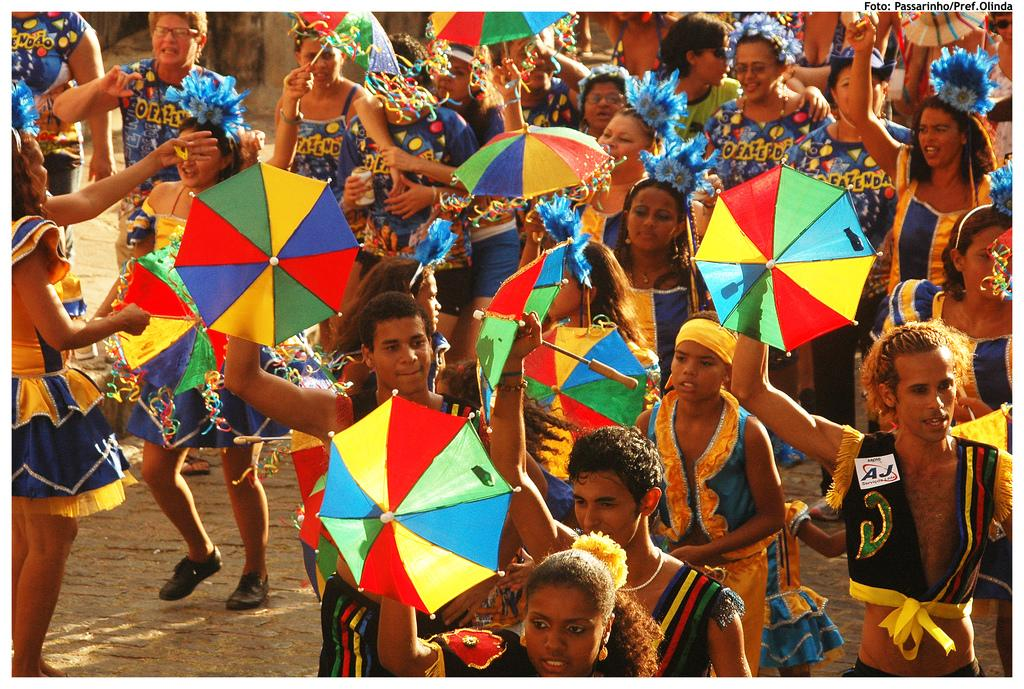<image>
Create a compact narrative representing the image presented. Group of people on a beach with one who's vest says AJ. 